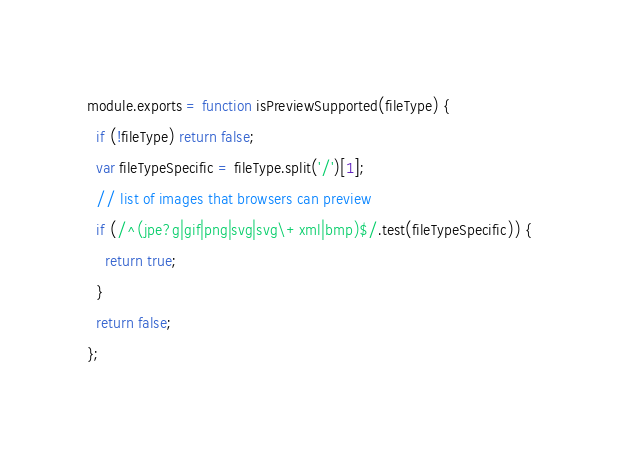Convert code to text. <code><loc_0><loc_0><loc_500><loc_500><_JavaScript_>module.exports = function isPreviewSupported(fileType) {
  if (!fileType) return false;
  var fileTypeSpecific = fileType.split('/')[1];
  // list of images that browsers can preview
  if (/^(jpe?g|gif|png|svg|svg\+xml|bmp)$/.test(fileTypeSpecific)) {
    return true;
  }
  return false;
};</code> 